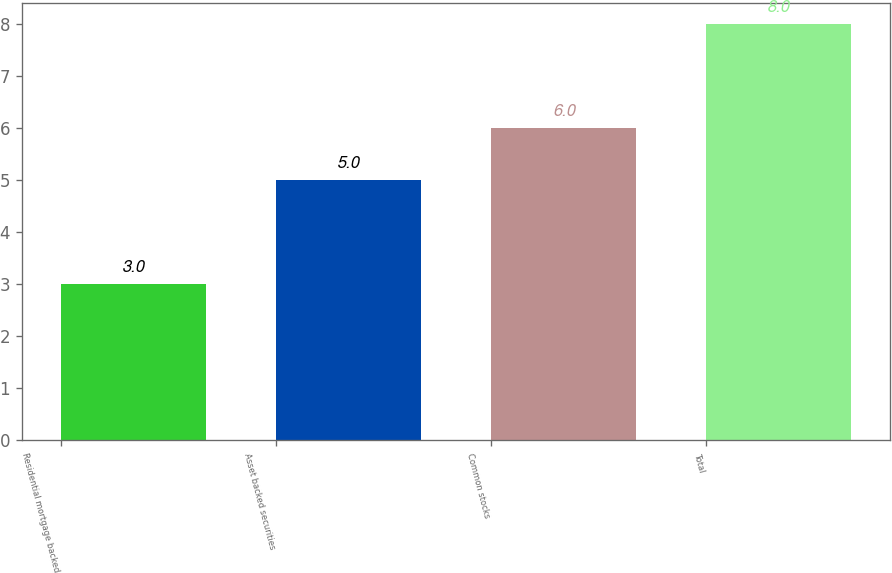Convert chart. <chart><loc_0><loc_0><loc_500><loc_500><bar_chart><fcel>Residential mortgage backed<fcel>Asset backed securities<fcel>Common stocks<fcel>Total<nl><fcel>3<fcel>5<fcel>6<fcel>8<nl></chart> 